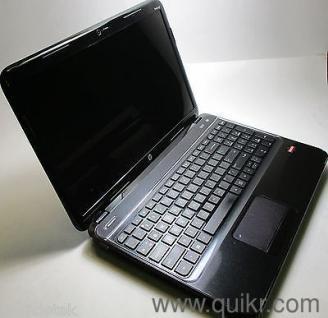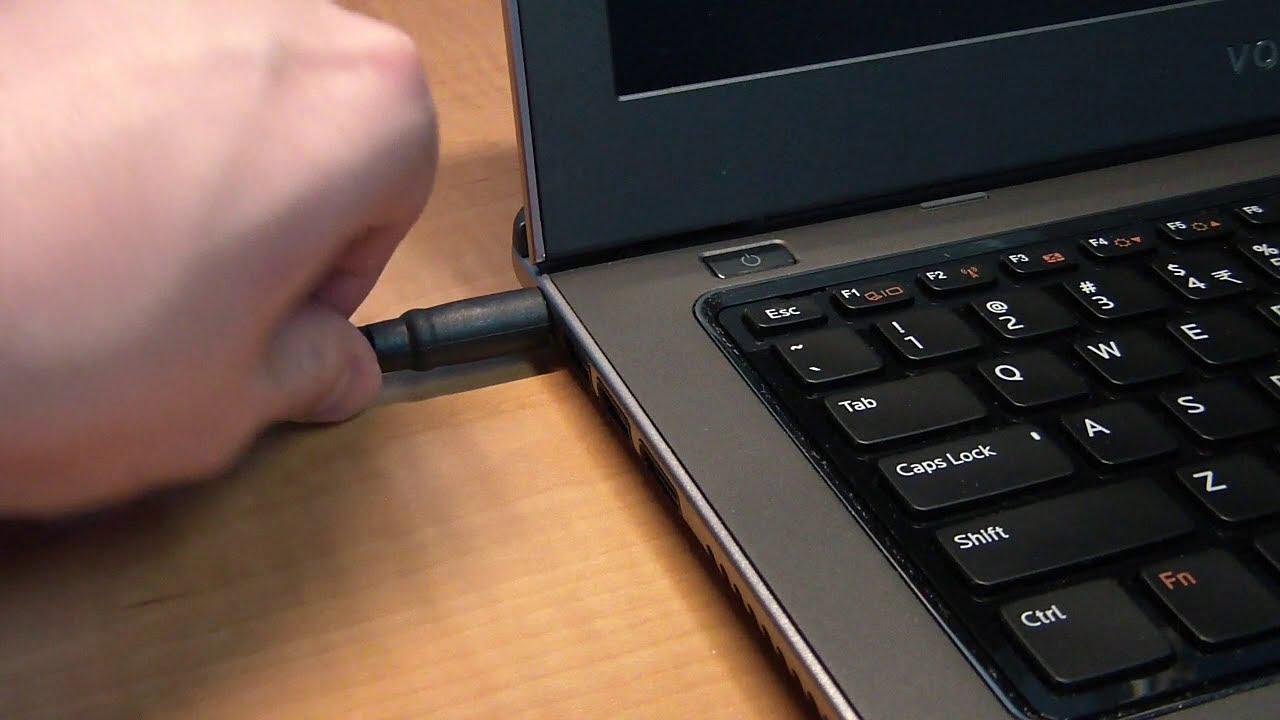The first image is the image on the left, the second image is the image on the right. For the images displayed, is the sentence "In at least one image there is a black laptop that is open and turned right." factually correct? Answer yes or no. Yes. The first image is the image on the left, the second image is the image on the right. Analyze the images presented: Is the assertion "One image shows a hand reaching for something plugged into the side of an open laptop." valid? Answer yes or no. Yes. 